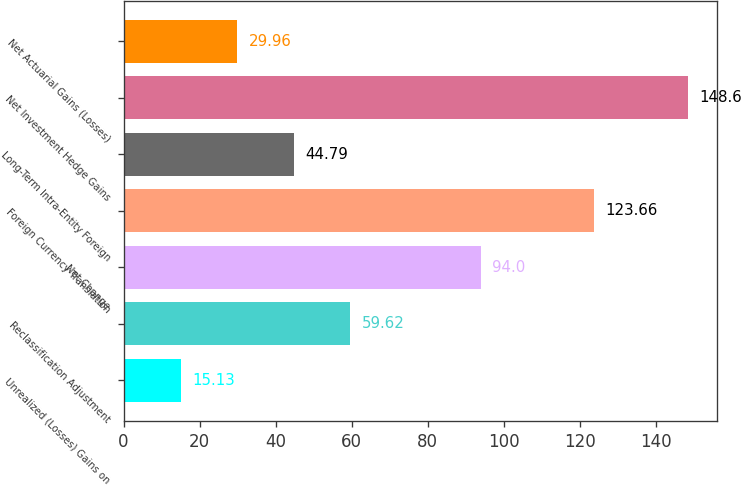<chart> <loc_0><loc_0><loc_500><loc_500><bar_chart><fcel>Unrealized (Losses) Gains on<fcel>Reclassification Adjustment<fcel>Net Change<fcel>Foreign Currency Translation<fcel>Long-Term Intra-Entity Foreign<fcel>Net Investment Hedge Gains<fcel>Net Actuarial Gains (Losses)<nl><fcel>15.13<fcel>59.62<fcel>94<fcel>123.66<fcel>44.79<fcel>148.6<fcel>29.96<nl></chart> 